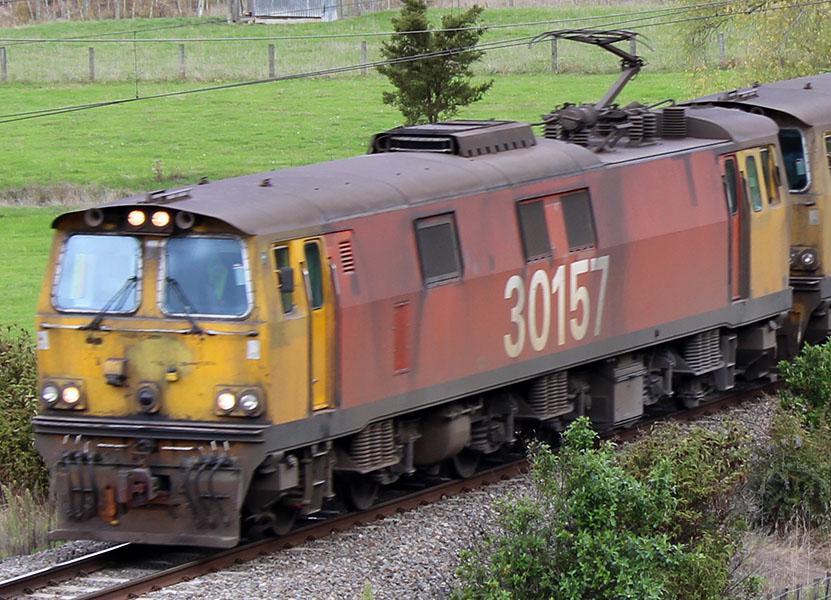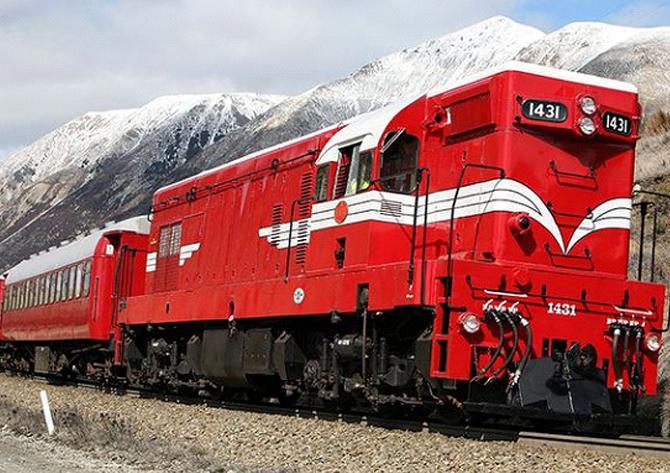The first image is the image on the left, the second image is the image on the right. Examine the images to the left and right. Is the description "read trains are facing the left of the image" accurate? Answer yes or no. No. The first image is the image on the left, the second image is the image on the right. For the images shown, is this caption "The engines in both images are have some red color and are facing to the left." true? Answer yes or no. No. 